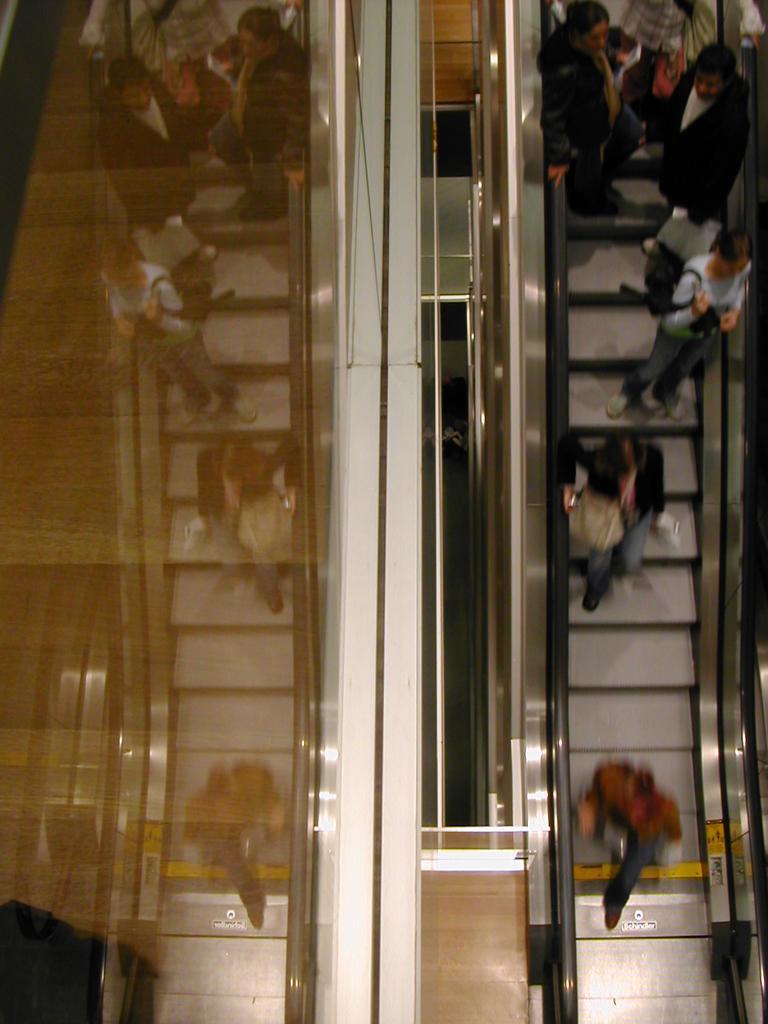Can you describe this image briefly? In this image we can see a few people standing on the escalator, some of them are holding bags, also we can see those reflections in the mirror. 